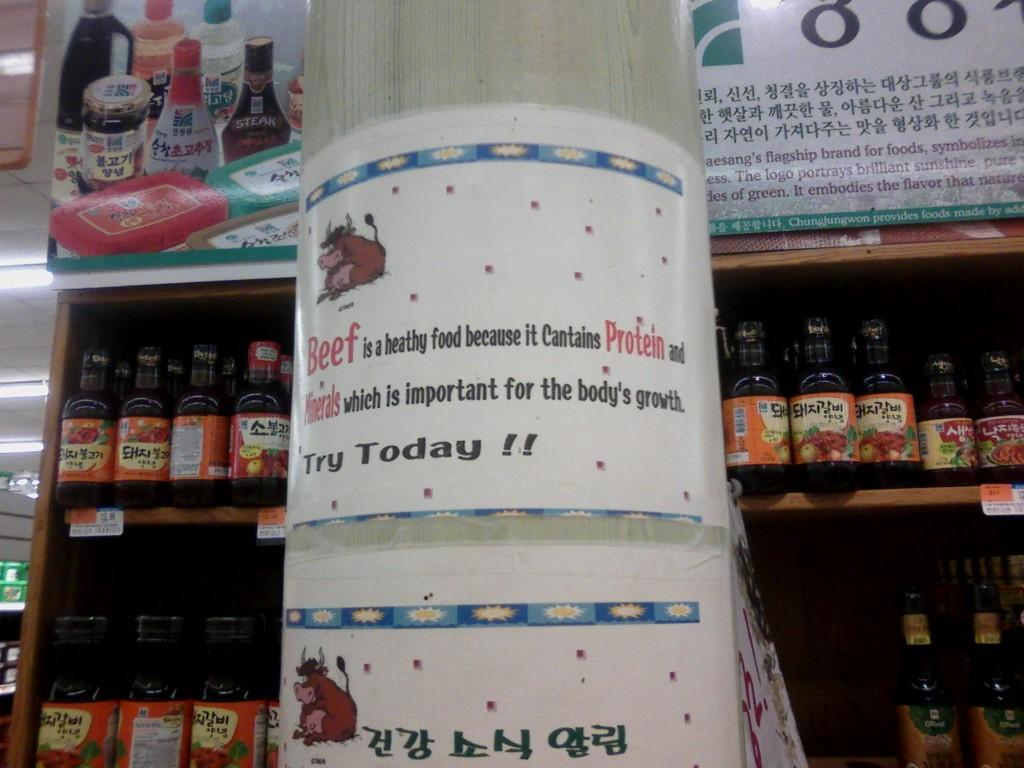<image>
Offer a succinct explanation of the picture presented. A sign on a post in a market that says beef is healthy food because it contains protein and mineral which is important for the body's growth. 